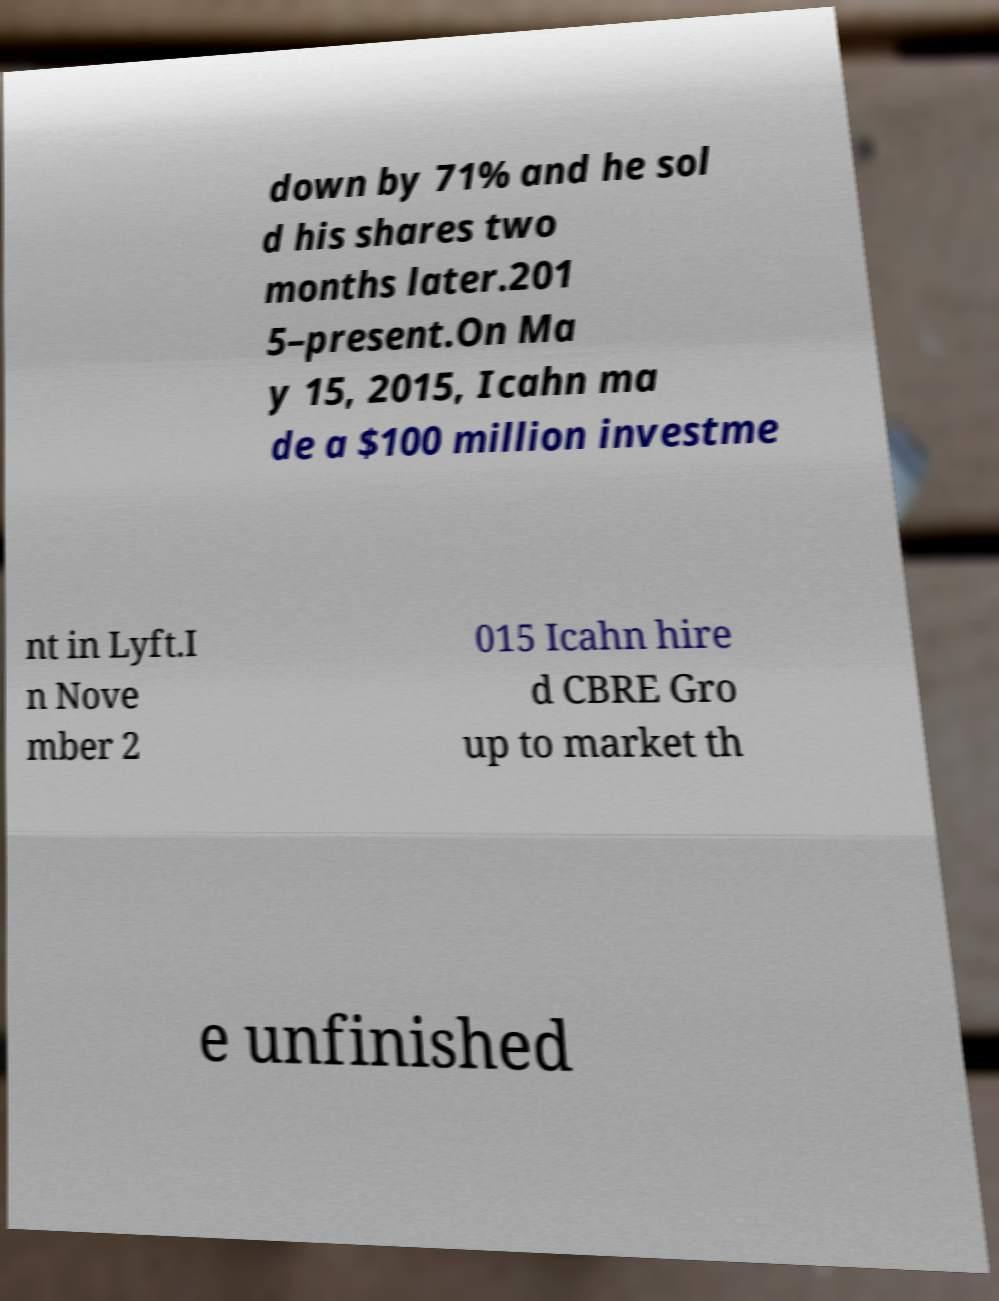Please read and relay the text visible in this image. What does it say? down by 71% and he sol d his shares two months later.201 5–present.On Ma y 15, 2015, Icahn ma de a $100 million investme nt in Lyft.I n Nove mber 2 015 Icahn hire d CBRE Gro up to market th e unfinished 